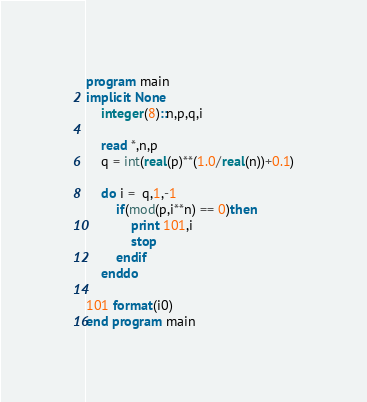<code> <loc_0><loc_0><loc_500><loc_500><_FORTRAN_>program main
implicit None
	integer(8)::n,p,q,i
	
	read *,n,p
	q = int(real(p)**(1.0/real(n))+0.1)
	
	do i =  q,1,-1
		if(mod(p,i**n) == 0)then
			print 101,i
			stop
		endif
	enddo
	
101 format(i0)
end program main</code> 